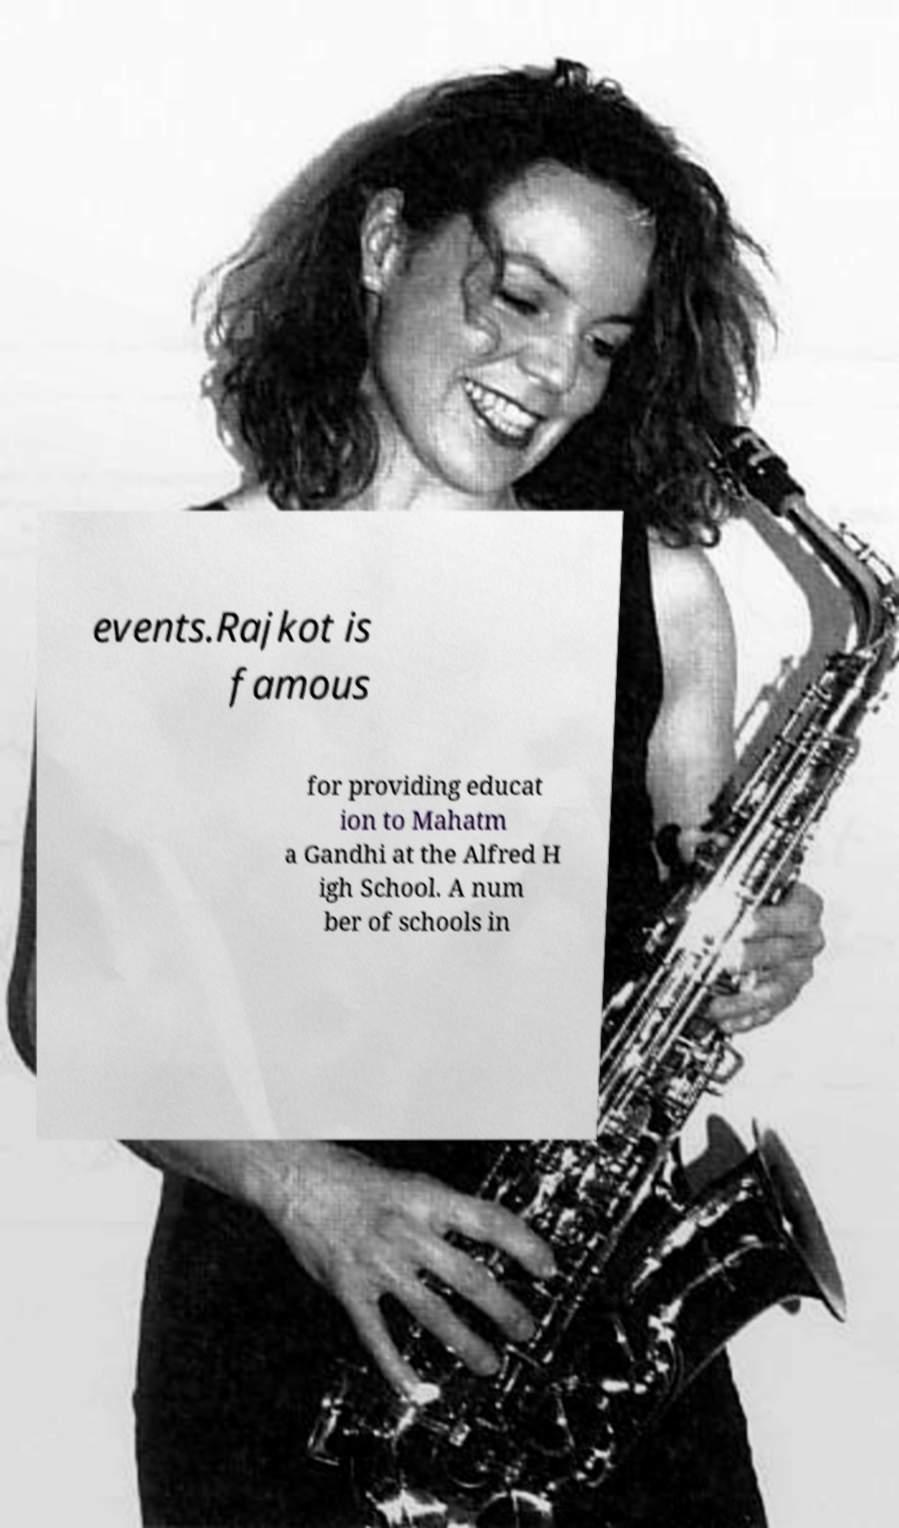Could you assist in decoding the text presented in this image and type it out clearly? events.Rajkot is famous for providing educat ion to Mahatm a Gandhi at the Alfred H igh School. A num ber of schools in 